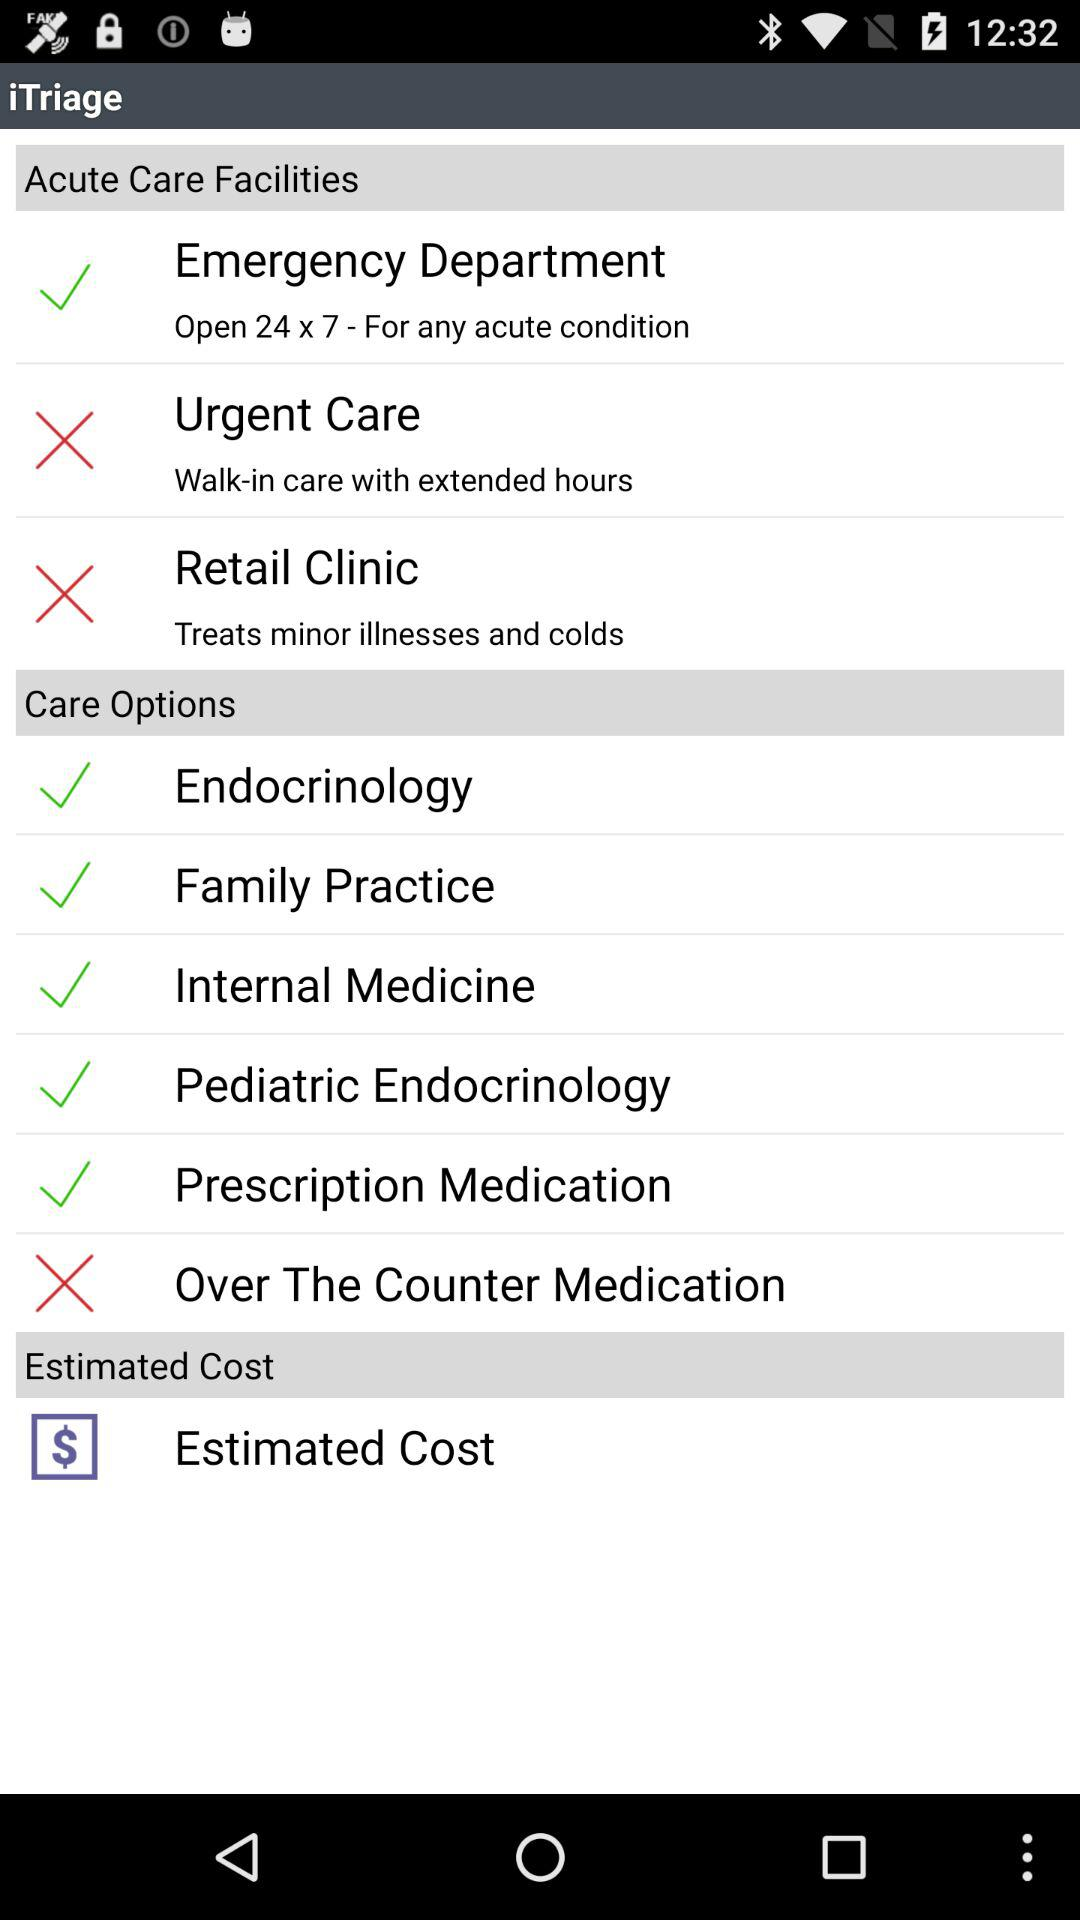Which department is open 24*7? The department is the emergency department. 